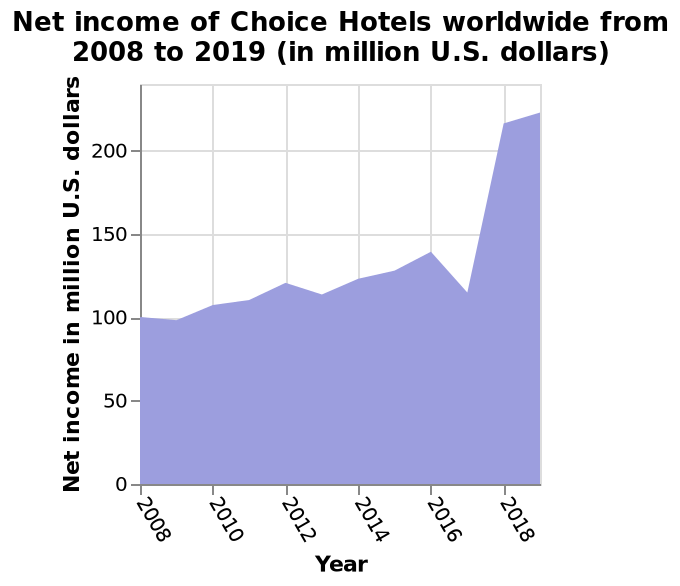<image>
Are there any factors or variables that might affect the visibility of trends on the graph?  It is possible that factors such as scale, time period, or data range might affect the visibility of trends on the graph. What is the unit of measurement on the y-axis? The unit of measurement on the y-axis is "Net income in million U.S. dollars". Is it impossible that factors such as scale, time period, or data range might affect the visibility of trends on the graph? No. It is possible that factors such as scale, time period, or data range might affect the visibility of trends on the graph. 